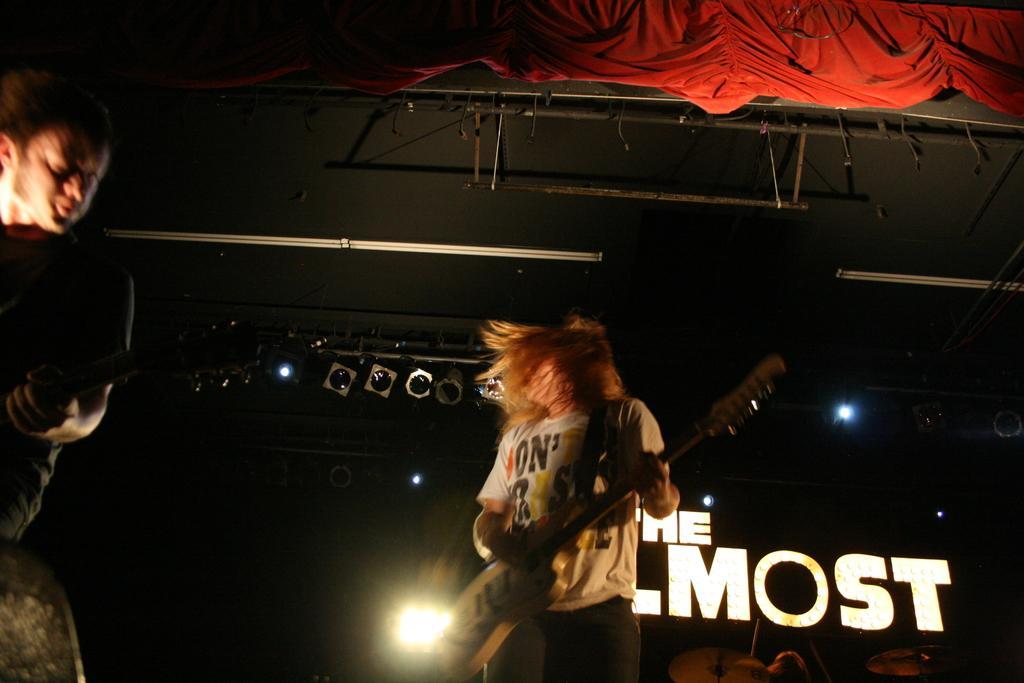Can you describe this image briefly? There are two members standing in the picture, playing a guitar in their hands. n the background we can observe some lights. There is a red curtain here, above the two members. 